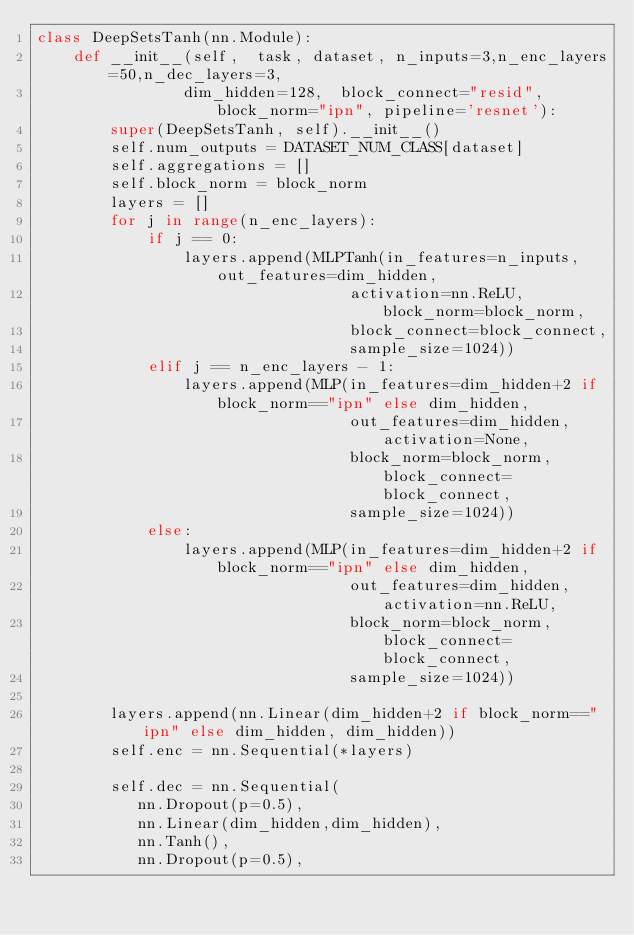<code> <loc_0><loc_0><loc_500><loc_500><_Python_>class DeepSetsTanh(nn.Module):
    def __init__(self,  task, dataset, n_inputs=3,n_enc_layers=50,n_dec_layers=3,
                dim_hidden=128,  block_connect="resid", block_norm="ipn", pipeline='resnet'):
        super(DeepSetsTanh, self).__init__()
        self.num_outputs = DATASET_NUM_CLASS[dataset]
        self.aggregations = []
        self.block_norm = block_norm
        layers = []
        for j in range(n_enc_layers):
            if j == 0:
                layers.append(MLPTanh(in_features=n_inputs, out_features=dim_hidden, 
                                  activation=nn.ReLU, block_norm=block_norm, 
                                  block_connect=block_connect, 
                                  sample_size=1024))  
            elif j == n_enc_layers - 1:
                layers.append(MLP(in_features=dim_hidden+2 if block_norm=="ipn" else dim_hidden, 
                                  out_features=dim_hidden, activation=None, 
                                  block_norm=block_norm, block_connect=block_connect,
                                  sample_size=1024))
            else:
                layers.append(MLP(in_features=dim_hidden+2 if block_norm=="ipn" else dim_hidden, 
                                  out_features=dim_hidden, activation=nn.ReLU, 
                                  block_norm=block_norm, block_connect=block_connect, 
                                  sample_size=1024))

        layers.append(nn.Linear(dim_hidden+2 if block_norm=="ipn" else dim_hidden, dim_hidden))
        self.enc = nn.Sequential(*layers)
            
        self.dec = nn.Sequential(
           nn.Dropout(p=0.5),
           nn.Linear(dim_hidden,dim_hidden),
           nn.Tanh(),
           nn.Dropout(p=0.5),</code> 